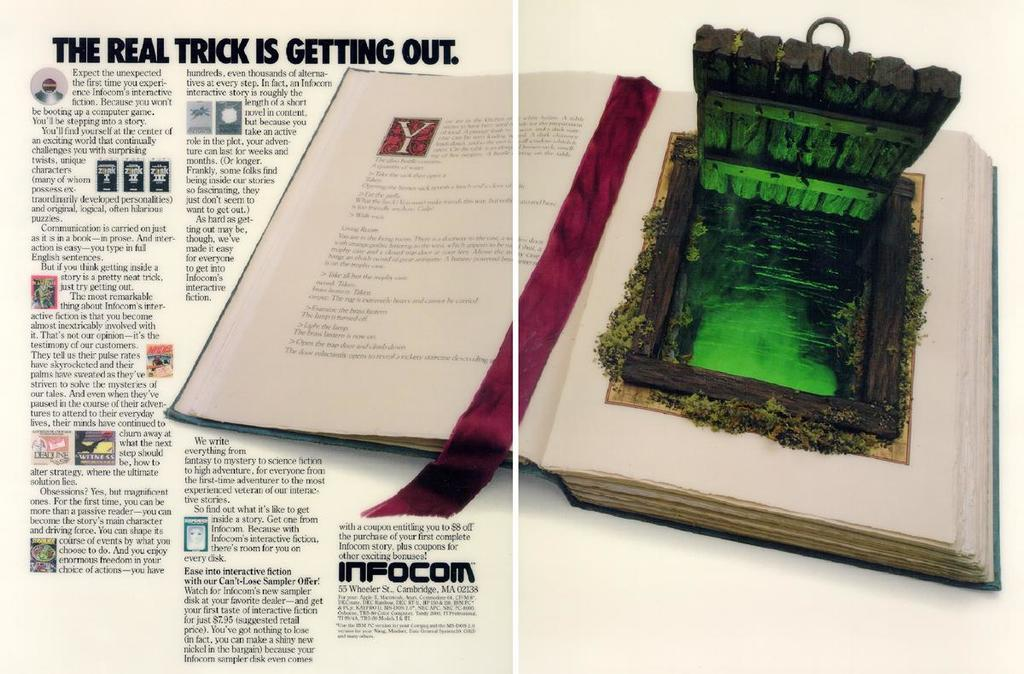<image>
Share a concise interpretation of the image provided. An Infocom ad tries to get people to buy the services. 